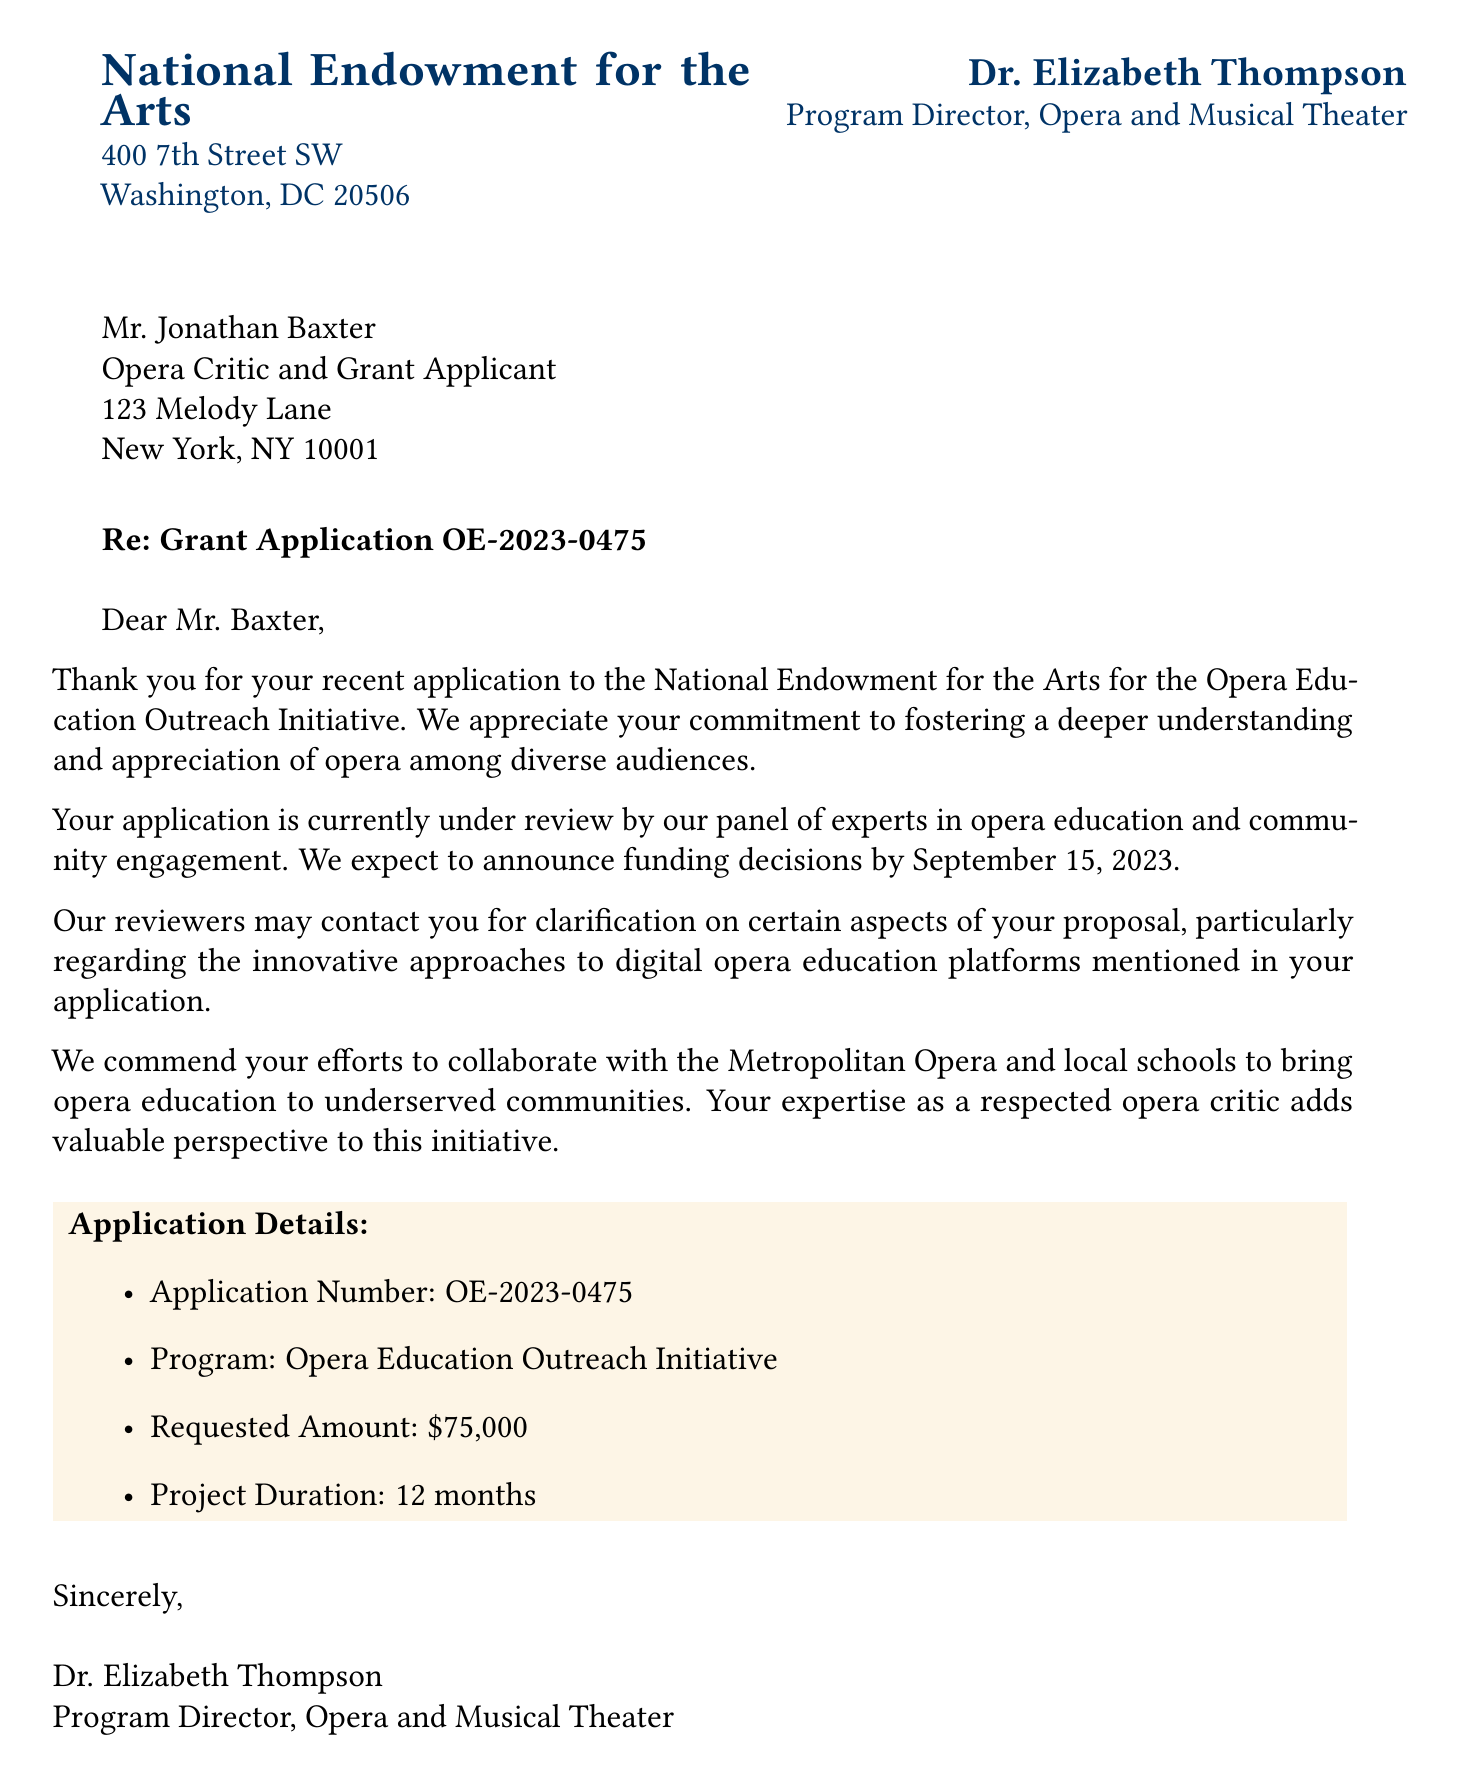What is the sender's name? The sender's name is mentioned at the beginning of the document as Dr. Elizabeth Thompson.
Answer: Dr. Elizabeth Thompson What is the applicant's requested amount? The requested amount is specified in the application details section of the document.
Answer: $75,000 What is the project duration? The project duration is provided in the application details section and refers to how long the project will run.
Answer: 12 months When will the funding decisions be announced? The document states the expected date for announcing funding decisions, crucial for understanding the timeline.
Answer: September 15, 2023 What is the purpose of the grant application? The purpose is outlined in the opening paragraph, which describes the initiative's aim to foster appreciation of opera.
Answer: Opera Education Outreach Initiative Who is the recipient's title? The recipient's title is stated directly beneath their name in the address section of the document.
Answer: Opera Critic and Grant Applicant What specific aspect of the proposal may require clarification? The document mentions a particular area of the proposal that could prompt the reviewers to reach out for further information.
Answer: Digital opera education platforms What kind of collaborations does the recipient mention? The collaborations referenced highlight the importance of partnerships in the initiative, mentioned as part of the closing remarks.
Answer: Metropolitan Opera and local schools 